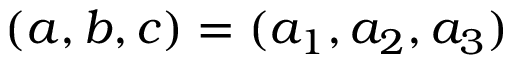Convert formula to latex. <formula><loc_0><loc_0><loc_500><loc_500>( a , b , c ) = ( a _ { 1 } , a _ { 2 } , a _ { 3 } )</formula> 